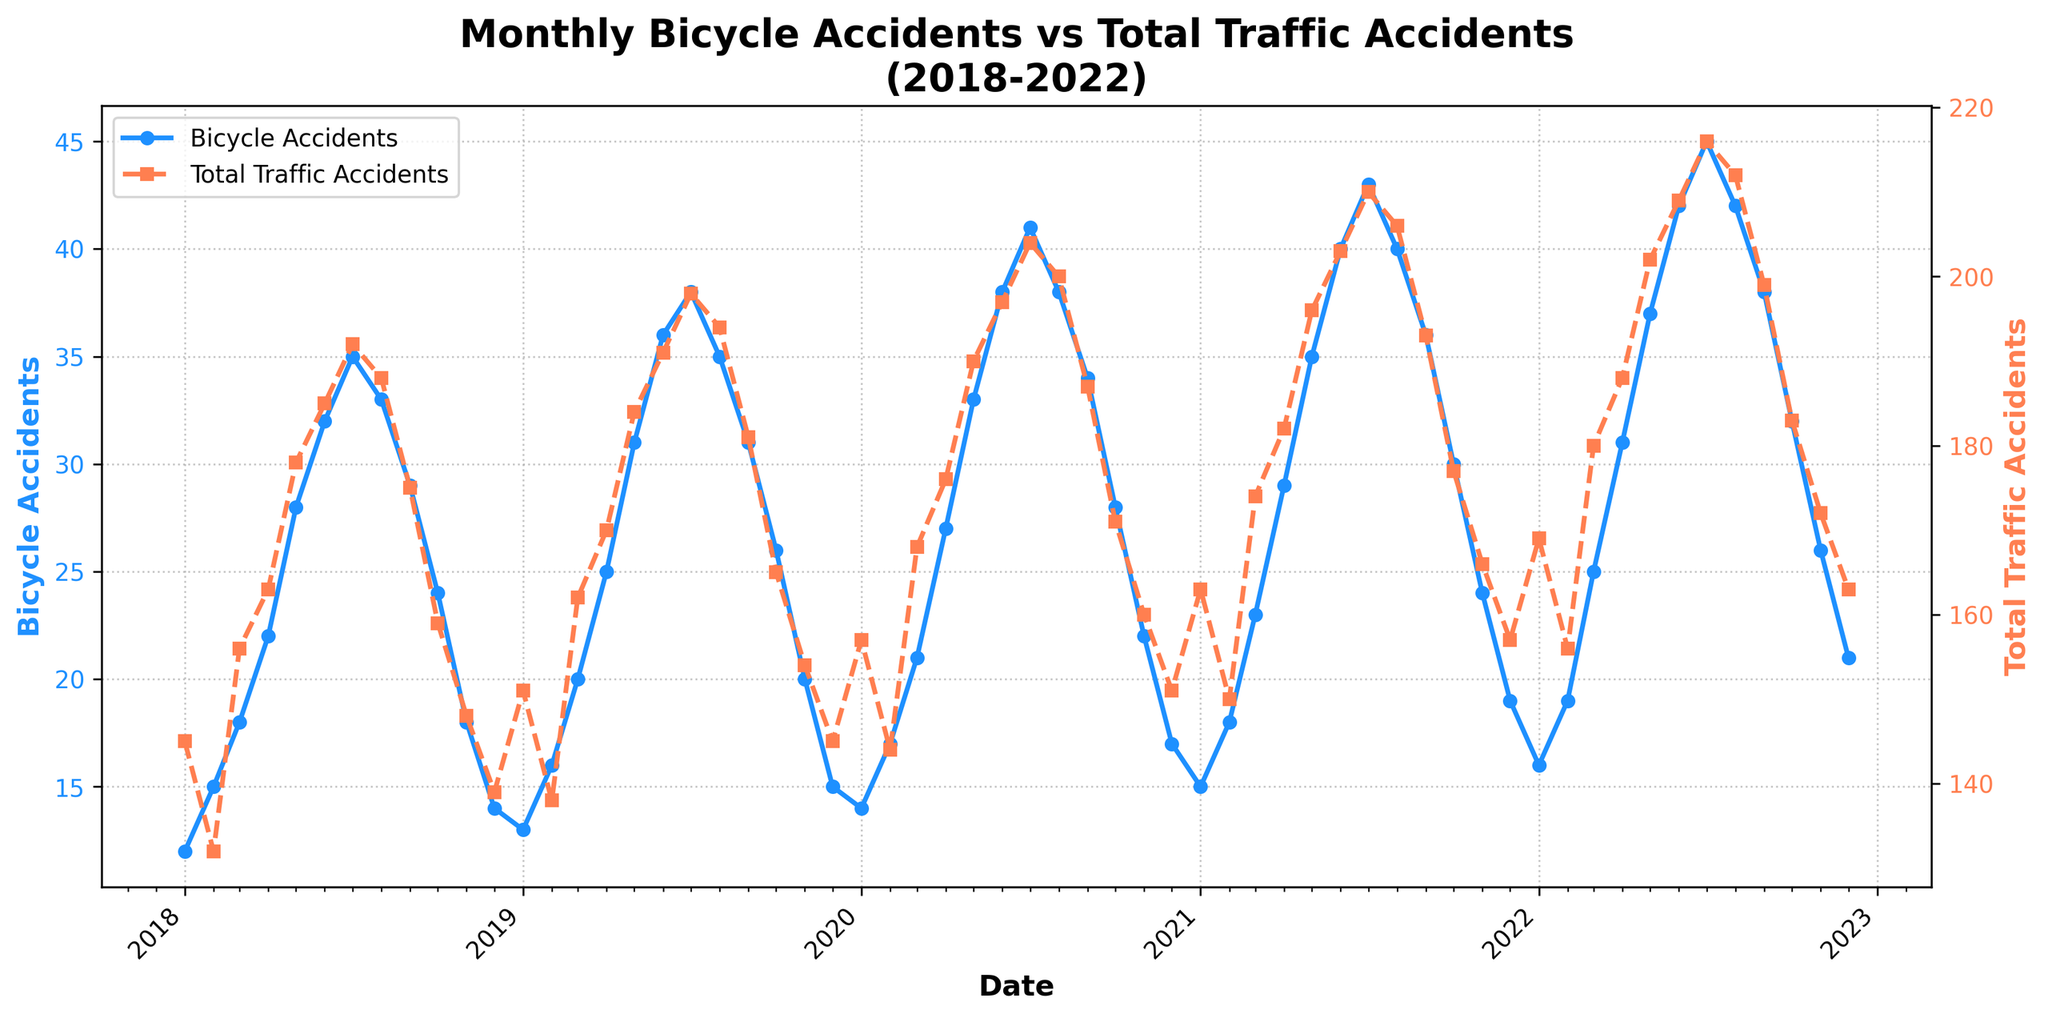What's the trend of monthly bicycle accidents over the 5-year period? The line representing monthly bicycle accidents starts lower in 2018 and shows an upward trend, peaking in mid-2022 before slightly lowering by the end of 2022. This indicates an overall increase in monthly bicycle accidents over the 5 years.
Answer: Increasing How do the peaks of bicycle accidents compare to those of total traffic accidents? The peaks for both bicycle and total traffic accidents occur around the middle of the year. Both reach their highest points in July of each year. This pattern suggests that accident rates for both bicycles and total traffic are highest during the summer months.
Answer: They peak together in July What is the largest difference between monthly bicycle accidents and total traffic accidents? The largest difference can be calculated by subtracting the number of bicycle accidents from the total traffic accidents each month and identifying the maximum value. For instance, in July 2022, the difference is 216 - 45 = 171.
Answer: 171 (in July 2022) What months see a decrease in bicycle accidents while total traffic accidents increase? We need to identify all months where the line representing bicycle accidents decreases while the line for total traffic accidents increases. Specifically, this occurs in August 2018, August 2019, and August 2020.
Answer: August 2018, August 2019, August 2020 Do bicycle accidents always decrease as total traffic accidents decrease towards the end of each year? By observing the trends, both bicycle accidents and total traffic accidents decrease towards the end of each year, particularly from September to December each year. This pattern is consistent throughout the 5-year period.
Answer: Yes Which year had the highest average monthly bicycle accidents? To find the year with the highest average, sum the monthly bicycle accidents for each year and divide by 12. Varying yearly averages need comparison: 
2018: 12+15+18+22+28+32+35+33+29+24+18+14 = 280 / 12 = 23.33
2019: 13+16+20+25+31+36+38+35+31+26+20+15 = 306 / 12 = 25.5
2020: 14+17+21+27+33+38+41+38+34+28+22+17 = 330 / 12 = 27.5
2021: 15+18+23+29+35+40+43+40+36+30+24+19 = 352 / 12 = 29.33
2022: 16+19+25+31+37+42+45+42+38+32+26+21 = 374 / 12 = 31.17 
Upon calculation, 2022 has the highest average.
Answer: 2022 What's the rate of increase of bicycle accidents from Jan 2018 to Dec 2022? Subtract the number of bicycle accidents in Jan 2018 from that in Dec 2022, then divide by the number of months (60) to find the monthly rate of increase. There were 12 accidents in Jan 2018 and 21 in Dec 2022, so (21 - 12) / 60 = 0.15 accidents per month increase.
Answer: 0.15 per month Which month in the 5-year period has the lowest number of bicycle accidents, and in what year? The lowest point of the blue line (bicycle accidents) on the chart identifies the minimum value. January 2018 has the fewest bicycle accidents with just 12 accidents reported.
Answer: January 2018 Are there any visual trends when overlaid lines for bicycle and total traffic accidents diverge significantly? Visual examination reveals divergence particularly in the summer months (July to August), where the difference between the two peaks is significantly pronounced. Highlighting the largest monthly differences provides insights.
Answer: Summer months, especially July 